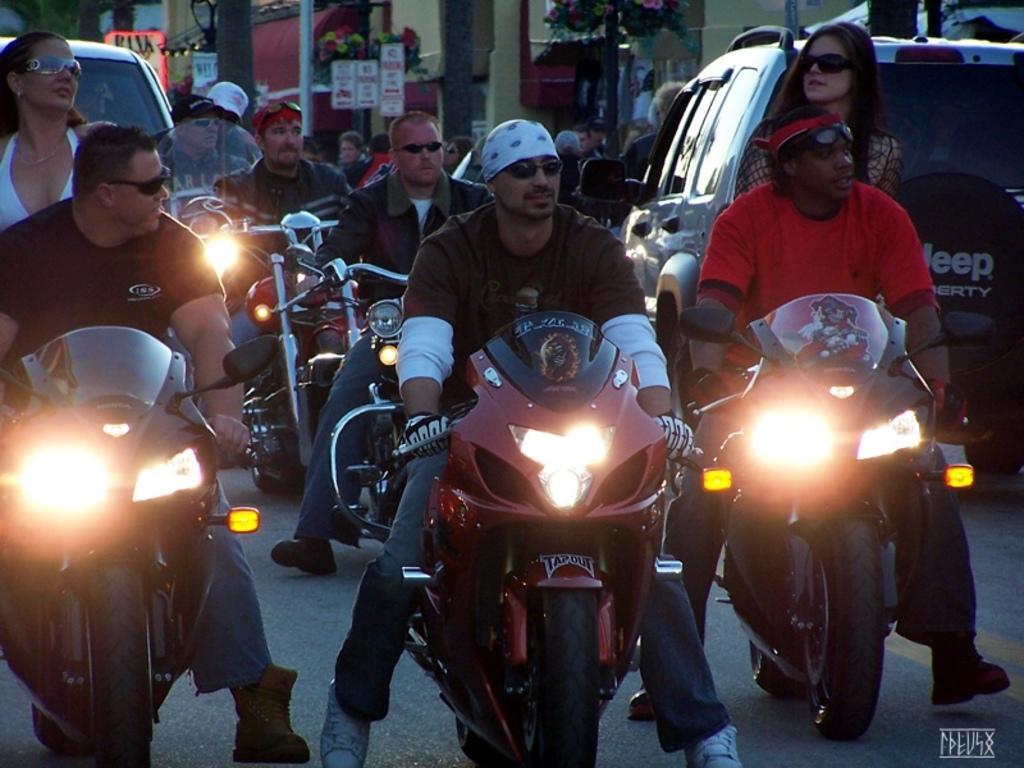Can you describe this image briefly? This image is clicked on the road. There are group of men on bikes and there is a jeep in the behind. This image seems to be off a bikers rally and in the background there are plants,pole and store front. 